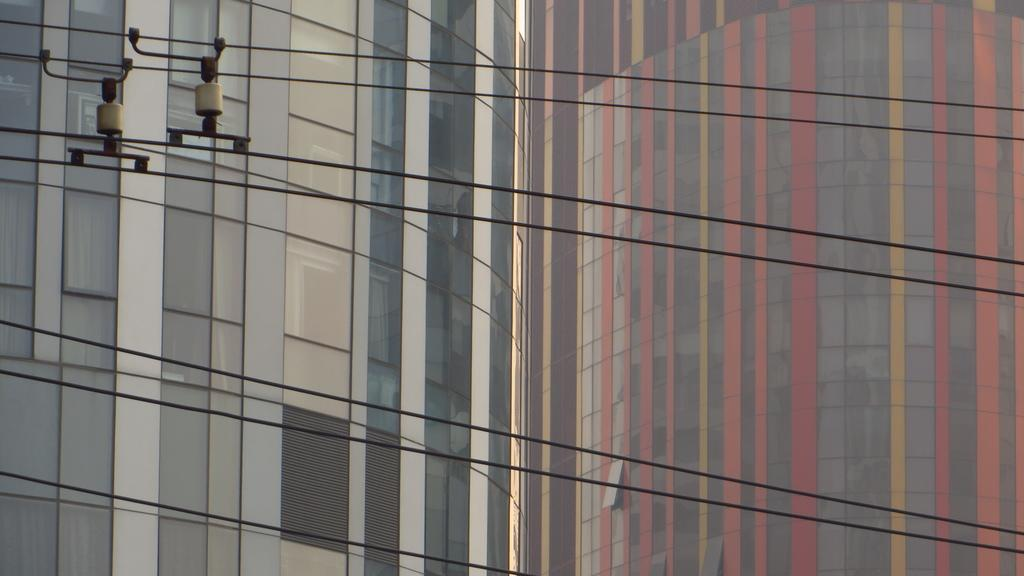What type of structures can be seen in the image? There are buildings in the image. What objects are present in the foreground of the image? There are rods on cables in the foreground of the image. What type of flower is the farmer holding in the image? There is no farmer or flower present in the image. What type of stove can be seen in the image? There is no stove present in the image. 